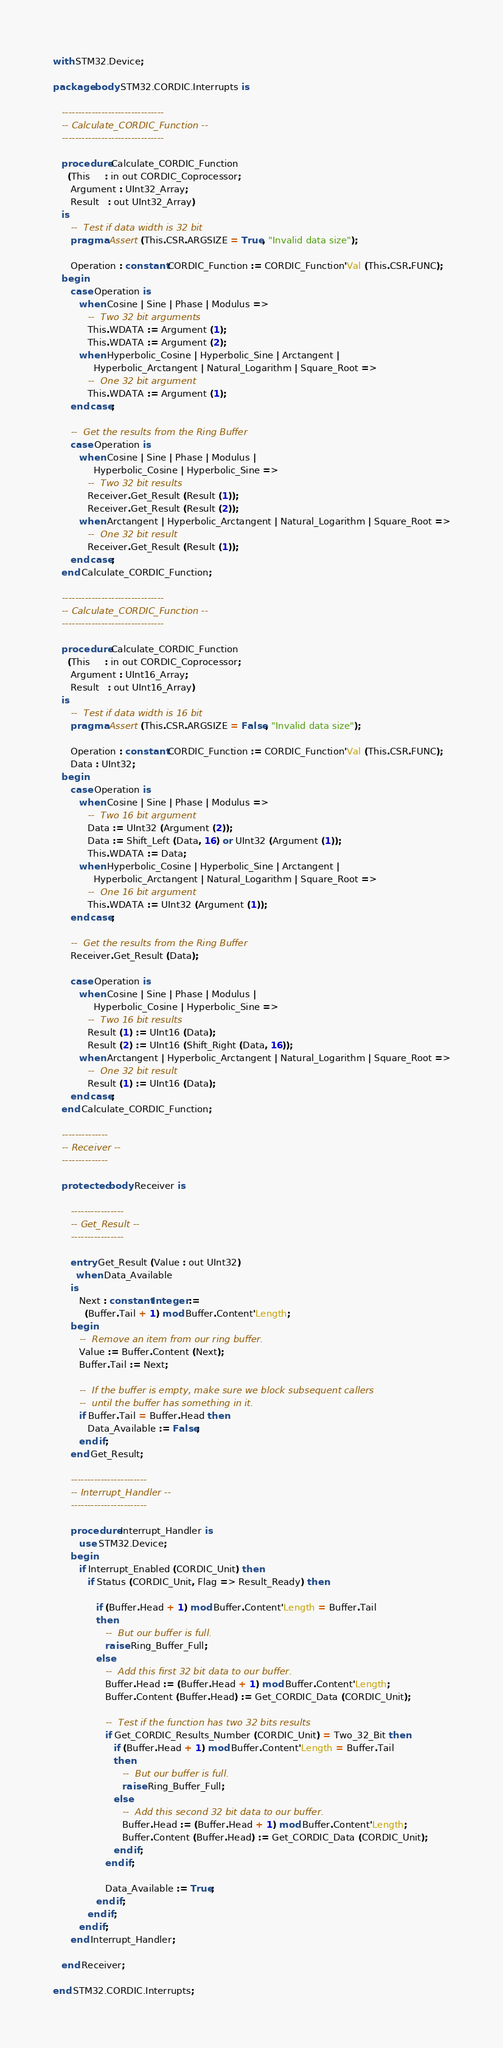<code> <loc_0><loc_0><loc_500><loc_500><_Ada_>with STM32.Device;

package body STM32.CORDIC.Interrupts is

   -------------------------------
   -- Calculate_CORDIC_Function --
   -------------------------------

   procedure Calculate_CORDIC_Function
     (This     : in out CORDIC_Coprocessor;
      Argument : UInt32_Array;
      Result   : out UInt32_Array)
   is
      --  Test if data width is 32 bit
      pragma Assert (This.CSR.ARGSIZE = True, "Invalid data size");

      Operation : constant CORDIC_Function := CORDIC_Function'Val (This.CSR.FUNC);
   begin
      case Operation is
         when Cosine | Sine | Phase | Modulus =>
            --  Two 32 bit arguments
            This.WDATA := Argument (1);
            This.WDATA := Argument (2);
         when Hyperbolic_Cosine | Hyperbolic_Sine | Arctangent |
              Hyperbolic_Arctangent | Natural_Logarithm | Square_Root =>
            --  One 32 bit argument
            This.WDATA := Argument (1);
      end case;

      --  Get the results from the Ring Buffer
      case Operation is
         when Cosine | Sine | Phase | Modulus |
              Hyperbolic_Cosine | Hyperbolic_Sine =>
            --  Two 32 bit results
            Receiver.Get_Result (Result (1));
            Receiver.Get_Result (Result (2));
         when Arctangent | Hyperbolic_Arctangent | Natural_Logarithm | Square_Root =>
            --  One 32 bit result
            Receiver.Get_Result (Result (1));
      end case;
   end Calculate_CORDIC_Function;

   -------------------------------
   -- Calculate_CORDIC_Function --
   -------------------------------

   procedure Calculate_CORDIC_Function
     (This     : in out CORDIC_Coprocessor;
      Argument : UInt16_Array;
      Result   : out UInt16_Array)
   is
      --  Test if data width is 16 bit
      pragma Assert (This.CSR.ARGSIZE = False, "Invalid data size");

      Operation : constant CORDIC_Function := CORDIC_Function'Val (This.CSR.FUNC);
      Data : UInt32;
   begin
      case Operation is
         when Cosine | Sine | Phase | Modulus =>
            --  Two 16 bit argument
            Data := UInt32 (Argument (2));
            Data := Shift_Left (Data, 16) or UInt32 (Argument (1));
            This.WDATA := Data;
         when Hyperbolic_Cosine | Hyperbolic_Sine | Arctangent |
              Hyperbolic_Arctangent | Natural_Logarithm | Square_Root =>
            --  One 16 bit argument
            This.WDATA := UInt32 (Argument (1));
      end case;

      --  Get the results from the Ring Buffer
      Receiver.Get_Result (Data);

      case Operation is
         when Cosine | Sine | Phase | Modulus |
              Hyperbolic_Cosine | Hyperbolic_Sine =>
            --  Two 16 bit results
            Result (1) := UInt16 (Data);
            Result (2) := UInt16 (Shift_Right (Data, 16));
         when Arctangent | Hyperbolic_Arctangent | Natural_Logarithm | Square_Root =>
            --  One 32 bit result
            Result (1) := UInt16 (Data);
      end case;
   end Calculate_CORDIC_Function;

   --------------
   -- Receiver --
   --------------

   protected body Receiver is

      ----------------
      -- Get_Result --
      ----------------

      entry Get_Result (Value : out UInt32)
        when Data_Available
      is
         Next : constant Integer :=
           (Buffer.Tail + 1) mod Buffer.Content'Length;
      begin
         --  Remove an item from our ring buffer.
         Value := Buffer.Content (Next);
         Buffer.Tail := Next;

         --  If the buffer is empty, make sure we block subsequent callers
         --  until the buffer has something in it.
         if Buffer.Tail = Buffer.Head then
            Data_Available := False;
         end if;
      end Get_Result;

      -----------------------
      -- Interrupt_Handler --
      -----------------------

      procedure Interrupt_Handler is
         use STM32.Device;
      begin
         if Interrupt_Enabled (CORDIC_Unit) then
            if Status (CORDIC_Unit, Flag => Result_Ready) then

               if (Buffer.Head + 1) mod Buffer.Content'Length = Buffer.Tail
               then
                  --  But our buffer is full.
                  raise Ring_Buffer_Full;
               else
                  --  Add this first 32 bit data to our buffer.
                  Buffer.Head := (Buffer.Head + 1) mod Buffer.Content'Length;
                  Buffer.Content (Buffer.Head) := Get_CORDIC_Data (CORDIC_Unit);

                  --  Test if the function has two 32 bits results
                  if Get_CORDIC_Results_Number (CORDIC_Unit) = Two_32_Bit then
                     if (Buffer.Head + 1) mod Buffer.Content'Length = Buffer.Tail
                     then
                        --  But our buffer is full.
                        raise Ring_Buffer_Full;
                     else
                        --  Add this second 32 bit data to our buffer.
                        Buffer.Head := (Buffer.Head + 1) mod Buffer.Content'Length;
                        Buffer.Content (Buffer.Head) := Get_CORDIC_Data (CORDIC_Unit);
                     end if;
                  end if;

                  Data_Available := True;
               end if;
            end if;
         end if;
      end Interrupt_Handler;

   end Receiver;

end STM32.CORDIC.Interrupts;
</code> 